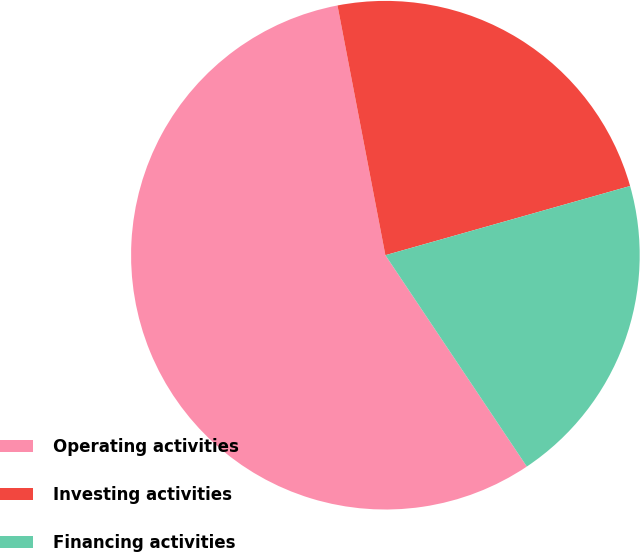Convert chart to OTSL. <chart><loc_0><loc_0><loc_500><loc_500><pie_chart><fcel>Operating activities<fcel>Investing activities<fcel>Financing activities<nl><fcel>56.37%<fcel>23.63%<fcel>20.0%<nl></chart> 